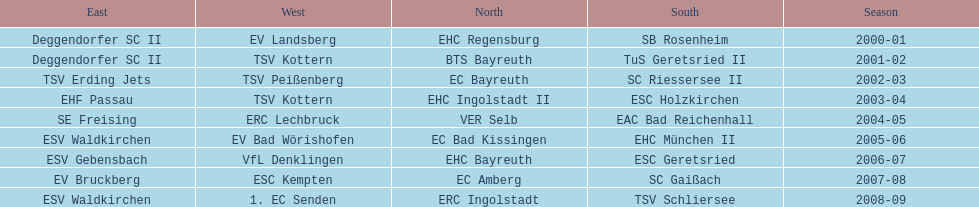Could you help me parse every detail presented in this table? {'header': ['East', 'West', 'North', 'South', 'Season'], 'rows': [['Deggendorfer SC II', 'EV Landsberg', 'EHC Regensburg', 'SB Rosenheim', '2000-01'], ['Deggendorfer SC II', 'TSV Kottern', 'BTS Bayreuth', 'TuS Geretsried II', '2001-02'], ['TSV Erding Jets', 'TSV Peißenberg', 'EC Bayreuth', 'SC Riessersee II', '2002-03'], ['EHF Passau', 'TSV Kottern', 'EHC Ingolstadt II', 'ESC Holzkirchen', '2003-04'], ['SE Freising', 'ERC Lechbruck', 'VER Selb', 'EAC Bad Reichenhall', '2004-05'], ['ESV Waldkirchen', 'EV Bad Wörishofen', 'EC Bad Kissingen', 'EHC München II', '2005-06'], ['ESV Gebensbach', 'VfL Denklingen', 'EHC Bayreuth', 'ESC Geretsried', '2006-07'], ['EV Bruckberg', 'ESC Kempten', 'EC Amberg', 'SC Gaißach', '2007-08'], ['ESV Waldkirchen', '1. EC Senden', 'ERC Ingolstadt', 'TSV Schliersee', '2008-09']]} Starting with the 2007 - 08 season, does ecs kempten appear in any of the previous years? No. 